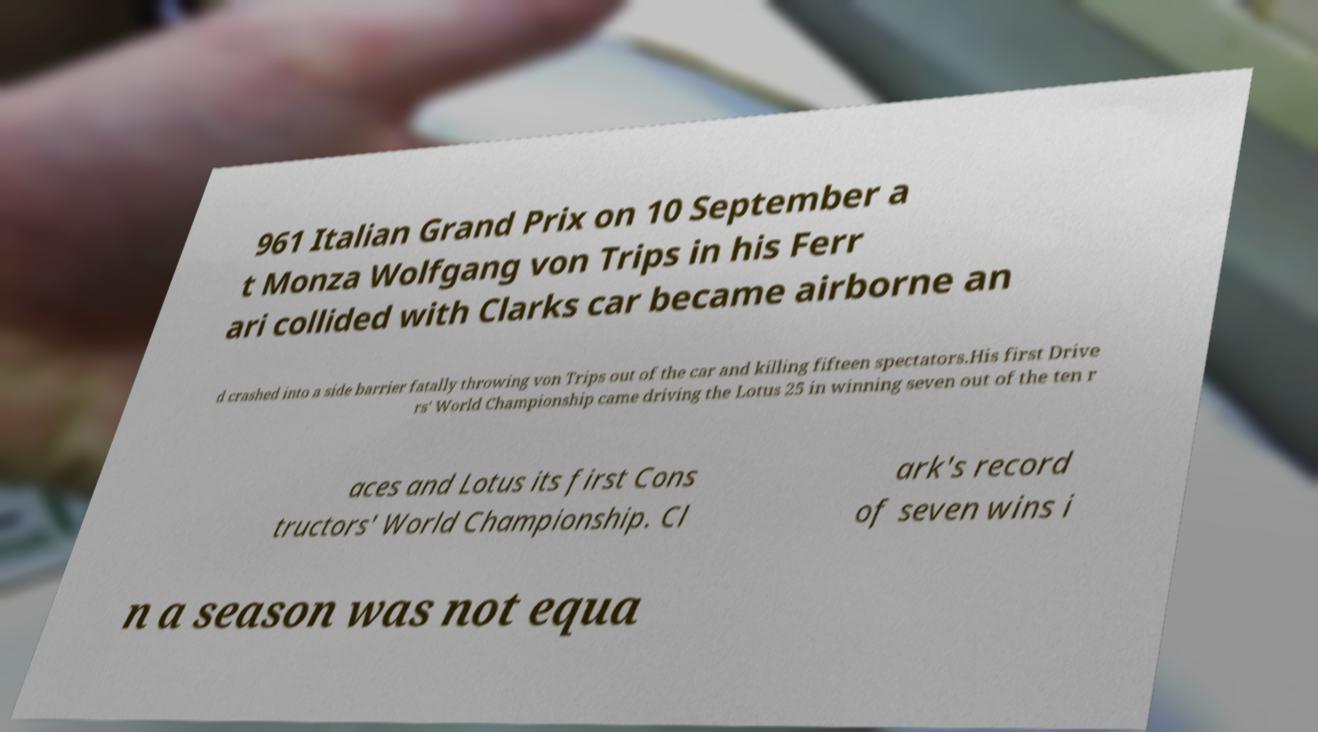For documentation purposes, I need the text within this image transcribed. Could you provide that? 961 Italian Grand Prix on 10 September a t Monza Wolfgang von Trips in his Ferr ari collided with Clarks car became airborne an d crashed into a side barrier fatally throwing von Trips out of the car and killing fifteen spectators.His first Drive rs' World Championship came driving the Lotus 25 in winning seven out of the ten r aces and Lotus its first Cons tructors' World Championship. Cl ark's record of seven wins i n a season was not equa 